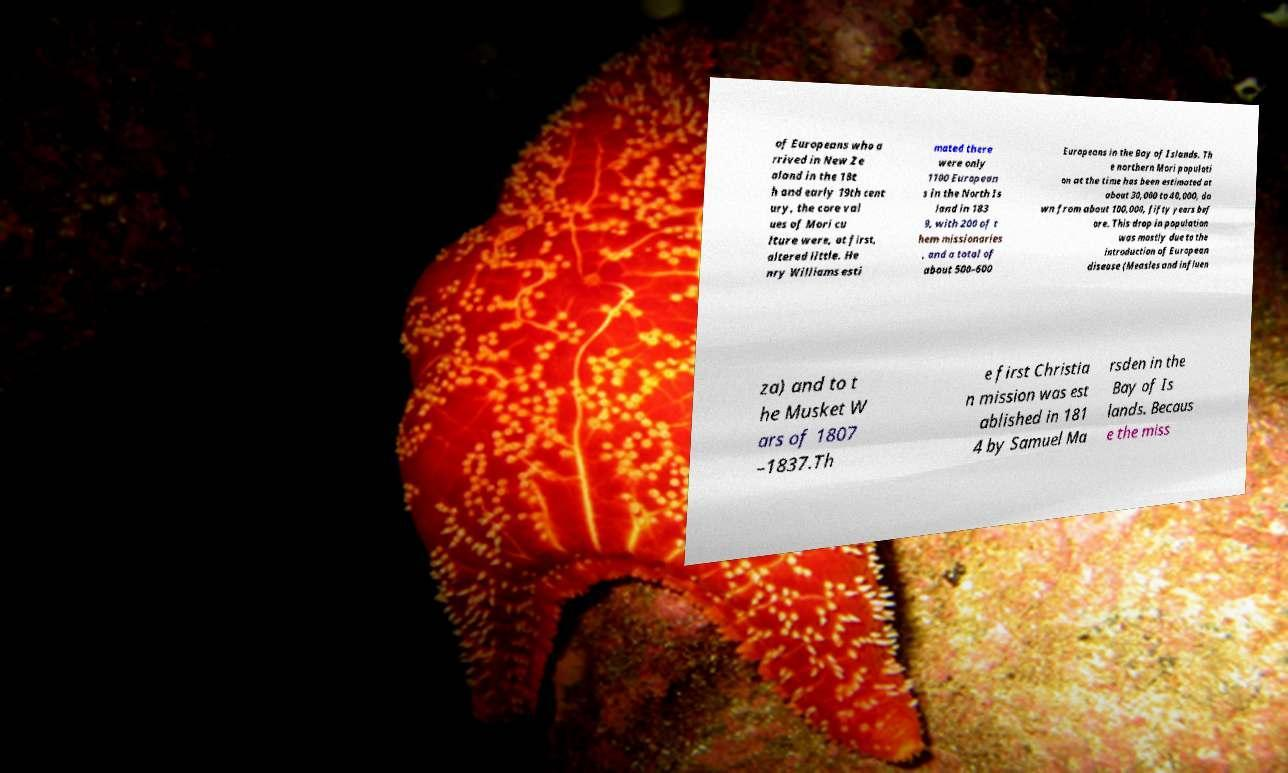I need the written content from this picture converted into text. Can you do that? of Europeans who a rrived in New Ze aland in the 18t h and early 19th cent ury, the core val ues of Mori cu lture were, at first, altered little. He nry Williams esti mated there were only 1100 European s in the North Is land in 183 9, with 200 of t hem missionaries , and a total of about 500–600 Europeans in the Bay of Islands. Th e northern Mori populati on at the time has been estimated at about 30,000 to 40,000, do wn from about 100,000, fifty years bef ore. This drop in population was mostly due to the introduction of European disease (Measles and influen za) and to t he Musket W ars of 1807 –1837.Th e first Christia n mission was est ablished in 181 4 by Samuel Ma rsden in the Bay of Is lands. Becaus e the miss 